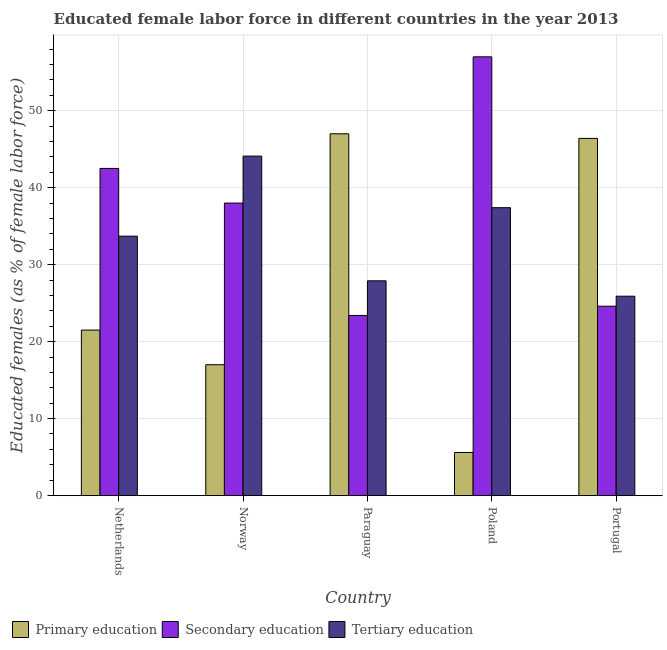How many different coloured bars are there?
Your response must be concise. 3. How many groups of bars are there?
Offer a very short reply. 5. How many bars are there on the 2nd tick from the left?
Provide a short and direct response. 3. How many bars are there on the 5th tick from the right?
Give a very brief answer. 3. What is the label of the 4th group of bars from the left?
Your answer should be very brief. Poland. What is the percentage of female labor force who received primary education in Poland?
Keep it short and to the point. 5.6. Across all countries, what is the maximum percentage of female labor force who received primary education?
Keep it short and to the point. 47. Across all countries, what is the minimum percentage of female labor force who received primary education?
Your answer should be very brief. 5.6. In which country was the percentage of female labor force who received primary education maximum?
Offer a terse response. Paraguay. In which country was the percentage of female labor force who received secondary education minimum?
Your answer should be very brief. Paraguay. What is the total percentage of female labor force who received tertiary education in the graph?
Offer a very short reply. 169. What is the difference between the percentage of female labor force who received primary education in Norway and that in Poland?
Ensure brevity in your answer.  11.4. What is the difference between the percentage of female labor force who received primary education in Norway and the percentage of female labor force who received secondary education in Netherlands?
Offer a very short reply. -25.5. What is the average percentage of female labor force who received secondary education per country?
Offer a very short reply. 37.1. What is the difference between the percentage of female labor force who received tertiary education and percentage of female labor force who received primary education in Portugal?
Keep it short and to the point. -20.5. In how many countries, is the percentage of female labor force who received primary education greater than 52 %?
Ensure brevity in your answer.  0. What is the ratio of the percentage of female labor force who received tertiary education in Netherlands to that in Norway?
Offer a terse response. 0.76. Is the percentage of female labor force who received secondary education in Norway less than that in Poland?
Provide a succinct answer. Yes. What is the difference between the highest and the second highest percentage of female labor force who received tertiary education?
Give a very brief answer. 6.7. What is the difference between the highest and the lowest percentage of female labor force who received tertiary education?
Make the answer very short. 18.2. Is the sum of the percentage of female labor force who received secondary education in Netherlands and Portugal greater than the maximum percentage of female labor force who received primary education across all countries?
Offer a very short reply. Yes. What does the 1st bar from the left in Paraguay represents?
Offer a terse response. Primary education. Are all the bars in the graph horizontal?
Your answer should be very brief. No. What is the difference between two consecutive major ticks on the Y-axis?
Provide a succinct answer. 10. Does the graph contain any zero values?
Offer a terse response. No. Does the graph contain grids?
Offer a very short reply. Yes. Where does the legend appear in the graph?
Provide a short and direct response. Bottom left. What is the title of the graph?
Ensure brevity in your answer.  Educated female labor force in different countries in the year 2013. Does "Labor Market" appear as one of the legend labels in the graph?
Your response must be concise. No. What is the label or title of the X-axis?
Provide a succinct answer. Country. What is the label or title of the Y-axis?
Offer a terse response. Educated females (as % of female labor force). What is the Educated females (as % of female labor force) in Primary education in Netherlands?
Ensure brevity in your answer.  21.5. What is the Educated females (as % of female labor force) in Secondary education in Netherlands?
Your answer should be very brief. 42.5. What is the Educated females (as % of female labor force) in Tertiary education in Netherlands?
Ensure brevity in your answer.  33.7. What is the Educated females (as % of female labor force) of Tertiary education in Norway?
Ensure brevity in your answer.  44.1. What is the Educated females (as % of female labor force) of Primary education in Paraguay?
Make the answer very short. 47. What is the Educated females (as % of female labor force) of Secondary education in Paraguay?
Your response must be concise. 23.4. What is the Educated females (as % of female labor force) of Tertiary education in Paraguay?
Make the answer very short. 27.9. What is the Educated females (as % of female labor force) in Primary education in Poland?
Offer a terse response. 5.6. What is the Educated females (as % of female labor force) in Secondary education in Poland?
Your answer should be very brief. 57. What is the Educated females (as % of female labor force) of Tertiary education in Poland?
Provide a short and direct response. 37.4. What is the Educated females (as % of female labor force) in Primary education in Portugal?
Offer a terse response. 46.4. What is the Educated females (as % of female labor force) in Secondary education in Portugal?
Give a very brief answer. 24.6. What is the Educated females (as % of female labor force) of Tertiary education in Portugal?
Your answer should be very brief. 25.9. Across all countries, what is the maximum Educated females (as % of female labor force) of Secondary education?
Your answer should be very brief. 57. Across all countries, what is the maximum Educated females (as % of female labor force) in Tertiary education?
Offer a very short reply. 44.1. Across all countries, what is the minimum Educated females (as % of female labor force) of Primary education?
Your answer should be very brief. 5.6. Across all countries, what is the minimum Educated females (as % of female labor force) of Secondary education?
Offer a terse response. 23.4. Across all countries, what is the minimum Educated females (as % of female labor force) in Tertiary education?
Keep it short and to the point. 25.9. What is the total Educated females (as % of female labor force) in Primary education in the graph?
Your answer should be compact. 137.5. What is the total Educated females (as % of female labor force) of Secondary education in the graph?
Offer a very short reply. 185.5. What is the total Educated females (as % of female labor force) in Tertiary education in the graph?
Make the answer very short. 169. What is the difference between the Educated females (as % of female labor force) of Primary education in Netherlands and that in Paraguay?
Make the answer very short. -25.5. What is the difference between the Educated females (as % of female labor force) of Secondary education in Netherlands and that in Paraguay?
Your answer should be compact. 19.1. What is the difference between the Educated females (as % of female labor force) of Tertiary education in Netherlands and that in Paraguay?
Offer a terse response. 5.8. What is the difference between the Educated females (as % of female labor force) of Primary education in Netherlands and that in Portugal?
Your answer should be very brief. -24.9. What is the difference between the Educated females (as % of female labor force) of Secondary education in Netherlands and that in Portugal?
Keep it short and to the point. 17.9. What is the difference between the Educated females (as % of female labor force) of Tertiary education in Norway and that in Paraguay?
Ensure brevity in your answer.  16.2. What is the difference between the Educated females (as % of female labor force) in Tertiary education in Norway and that in Poland?
Give a very brief answer. 6.7. What is the difference between the Educated females (as % of female labor force) in Primary education in Norway and that in Portugal?
Your response must be concise. -29.4. What is the difference between the Educated females (as % of female labor force) of Secondary education in Norway and that in Portugal?
Provide a short and direct response. 13.4. What is the difference between the Educated females (as % of female labor force) in Primary education in Paraguay and that in Poland?
Ensure brevity in your answer.  41.4. What is the difference between the Educated females (as % of female labor force) in Secondary education in Paraguay and that in Poland?
Make the answer very short. -33.6. What is the difference between the Educated females (as % of female labor force) of Secondary education in Paraguay and that in Portugal?
Ensure brevity in your answer.  -1.2. What is the difference between the Educated females (as % of female labor force) of Primary education in Poland and that in Portugal?
Provide a short and direct response. -40.8. What is the difference between the Educated females (as % of female labor force) of Secondary education in Poland and that in Portugal?
Make the answer very short. 32.4. What is the difference between the Educated females (as % of female labor force) of Primary education in Netherlands and the Educated females (as % of female labor force) of Secondary education in Norway?
Offer a terse response. -16.5. What is the difference between the Educated females (as % of female labor force) of Primary education in Netherlands and the Educated females (as % of female labor force) of Tertiary education in Norway?
Your answer should be compact. -22.6. What is the difference between the Educated females (as % of female labor force) in Secondary education in Netherlands and the Educated females (as % of female labor force) in Tertiary education in Paraguay?
Ensure brevity in your answer.  14.6. What is the difference between the Educated females (as % of female labor force) of Primary education in Netherlands and the Educated females (as % of female labor force) of Secondary education in Poland?
Your answer should be very brief. -35.5. What is the difference between the Educated females (as % of female labor force) of Primary education in Netherlands and the Educated females (as % of female labor force) of Tertiary education in Poland?
Your answer should be compact. -15.9. What is the difference between the Educated females (as % of female labor force) of Primary education in Netherlands and the Educated females (as % of female labor force) of Secondary education in Portugal?
Offer a terse response. -3.1. What is the difference between the Educated females (as % of female labor force) in Primary education in Netherlands and the Educated females (as % of female labor force) in Tertiary education in Portugal?
Your answer should be very brief. -4.4. What is the difference between the Educated females (as % of female labor force) in Secondary education in Netherlands and the Educated females (as % of female labor force) in Tertiary education in Portugal?
Offer a terse response. 16.6. What is the difference between the Educated females (as % of female labor force) of Primary education in Norway and the Educated females (as % of female labor force) of Secondary education in Paraguay?
Your response must be concise. -6.4. What is the difference between the Educated females (as % of female labor force) in Primary education in Norway and the Educated females (as % of female labor force) in Secondary education in Poland?
Provide a succinct answer. -40. What is the difference between the Educated females (as % of female labor force) of Primary education in Norway and the Educated females (as % of female labor force) of Tertiary education in Poland?
Your answer should be compact. -20.4. What is the difference between the Educated females (as % of female labor force) in Secondary education in Norway and the Educated females (as % of female labor force) in Tertiary education in Poland?
Offer a very short reply. 0.6. What is the difference between the Educated females (as % of female labor force) in Primary education in Norway and the Educated females (as % of female labor force) in Tertiary education in Portugal?
Ensure brevity in your answer.  -8.9. What is the difference between the Educated females (as % of female labor force) of Primary education in Paraguay and the Educated females (as % of female labor force) of Secondary education in Poland?
Offer a very short reply. -10. What is the difference between the Educated females (as % of female labor force) of Primary education in Paraguay and the Educated females (as % of female labor force) of Tertiary education in Poland?
Offer a very short reply. 9.6. What is the difference between the Educated females (as % of female labor force) in Secondary education in Paraguay and the Educated females (as % of female labor force) in Tertiary education in Poland?
Offer a terse response. -14. What is the difference between the Educated females (as % of female labor force) of Primary education in Paraguay and the Educated females (as % of female labor force) of Secondary education in Portugal?
Provide a short and direct response. 22.4. What is the difference between the Educated females (as % of female labor force) in Primary education in Paraguay and the Educated females (as % of female labor force) in Tertiary education in Portugal?
Keep it short and to the point. 21.1. What is the difference between the Educated females (as % of female labor force) in Secondary education in Paraguay and the Educated females (as % of female labor force) in Tertiary education in Portugal?
Your answer should be very brief. -2.5. What is the difference between the Educated females (as % of female labor force) in Primary education in Poland and the Educated females (as % of female labor force) in Tertiary education in Portugal?
Provide a succinct answer. -20.3. What is the difference between the Educated females (as % of female labor force) in Secondary education in Poland and the Educated females (as % of female labor force) in Tertiary education in Portugal?
Keep it short and to the point. 31.1. What is the average Educated females (as % of female labor force) in Secondary education per country?
Ensure brevity in your answer.  37.1. What is the average Educated females (as % of female labor force) of Tertiary education per country?
Keep it short and to the point. 33.8. What is the difference between the Educated females (as % of female labor force) in Primary education and Educated females (as % of female labor force) in Tertiary education in Netherlands?
Offer a very short reply. -12.2. What is the difference between the Educated females (as % of female labor force) of Secondary education and Educated females (as % of female labor force) of Tertiary education in Netherlands?
Keep it short and to the point. 8.8. What is the difference between the Educated females (as % of female labor force) of Primary education and Educated females (as % of female labor force) of Secondary education in Norway?
Your answer should be very brief. -21. What is the difference between the Educated females (as % of female labor force) of Primary education and Educated females (as % of female labor force) of Tertiary education in Norway?
Provide a short and direct response. -27.1. What is the difference between the Educated females (as % of female labor force) in Secondary education and Educated females (as % of female labor force) in Tertiary education in Norway?
Your response must be concise. -6.1. What is the difference between the Educated females (as % of female labor force) of Primary education and Educated females (as % of female labor force) of Secondary education in Paraguay?
Offer a terse response. 23.6. What is the difference between the Educated females (as % of female labor force) in Primary education and Educated females (as % of female labor force) in Secondary education in Poland?
Offer a very short reply. -51.4. What is the difference between the Educated females (as % of female labor force) of Primary education and Educated females (as % of female labor force) of Tertiary education in Poland?
Give a very brief answer. -31.8. What is the difference between the Educated females (as % of female labor force) of Secondary education and Educated females (as % of female labor force) of Tertiary education in Poland?
Ensure brevity in your answer.  19.6. What is the difference between the Educated females (as % of female labor force) in Primary education and Educated females (as % of female labor force) in Secondary education in Portugal?
Offer a very short reply. 21.8. What is the difference between the Educated females (as % of female labor force) in Secondary education and Educated females (as % of female labor force) in Tertiary education in Portugal?
Keep it short and to the point. -1.3. What is the ratio of the Educated females (as % of female labor force) in Primary education in Netherlands to that in Norway?
Ensure brevity in your answer.  1.26. What is the ratio of the Educated females (as % of female labor force) in Secondary education in Netherlands to that in Norway?
Keep it short and to the point. 1.12. What is the ratio of the Educated females (as % of female labor force) of Tertiary education in Netherlands to that in Norway?
Make the answer very short. 0.76. What is the ratio of the Educated females (as % of female labor force) in Primary education in Netherlands to that in Paraguay?
Your answer should be very brief. 0.46. What is the ratio of the Educated females (as % of female labor force) in Secondary education in Netherlands to that in Paraguay?
Make the answer very short. 1.82. What is the ratio of the Educated females (as % of female labor force) in Tertiary education in Netherlands to that in Paraguay?
Make the answer very short. 1.21. What is the ratio of the Educated females (as % of female labor force) of Primary education in Netherlands to that in Poland?
Ensure brevity in your answer.  3.84. What is the ratio of the Educated females (as % of female labor force) of Secondary education in Netherlands to that in Poland?
Your answer should be compact. 0.75. What is the ratio of the Educated females (as % of female labor force) in Tertiary education in Netherlands to that in Poland?
Ensure brevity in your answer.  0.9. What is the ratio of the Educated females (as % of female labor force) in Primary education in Netherlands to that in Portugal?
Your response must be concise. 0.46. What is the ratio of the Educated females (as % of female labor force) in Secondary education in Netherlands to that in Portugal?
Your answer should be compact. 1.73. What is the ratio of the Educated females (as % of female labor force) in Tertiary education in Netherlands to that in Portugal?
Offer a terse response. 1.3. What is the ratio of the Educated females (as % of female labor force) in Primary education in Norway to that in Paraguay?
Your answer should be very brief. 0.36. What is the ratio of the Educated females (as % of female labor force) of Secondary education in Norway to that in Paraguay?
Keep it short and to the point. 1.62. What is the ratio of the Educated females (as % of female labor force) in Tertiary education in Norway to that in Paraguay?
Make the answer very short. 1.58. What is the ratio of the Educated females (as % of female labor force) of Primary education in Norway to that in Poland?
Your answer should be very brief. 3.04. What is the ratio of the Educated females (as % of female labor force) in Secondary education in Norway to that in Poland?
Your response must be concise. 0.67. What is the ratio of the Educated females (as % of female labor force) in Tertiary education in Norway to that in Poland?
Your response must be concise. 1.18. What is the ratio of the Educated females (as % of female labor force) in Primary education in Norway to that in Portugal?
Offer a terse response. 0.37. What is the ratio of the Educated females (as % of female labor force) of Secondary education in Norway to that in Portugal?
Your answer should be very brief. 1.54. What is the ratio of the Educated females (as % of female labor force) in Tertiary education in Norway to that in Portugal?
Give a very brief answer. 1.7. What is the ratio of the Educated females (as % of female labor force) of Primary education in Paraguay to that in Poland?
Your response must be concise. 8.39. What is the ratio of the Educated females (as % of female labor force) in Secondary education in Paraguay to that in Poland?
Offer a terse response. 0.41. What is the ratio of the Educated females (as % of female labor force) in Tertiary education in Paraguay to that in Poland?
Keep it short and to the point. 0.75. What is the ratio of the Educated females (as % of female labor force) in Primary education in Paraguay to that in Portugal?
Ensure brevity in your answer.  1.01. What is the ratio of the Educated females (as % of female labor force) of Secondary education in Paraguay to that in Portugal?
Offer a terse response. 0.95. What is the ratio of the Educated females (as % of female labor force) in Tertiary education in Paraguay to that in Portugal?
Provide a succinct answer. 1.08. What is the ratio of the Educated females (as % of female labor force) in Primary education in Poland to that in Portugal?
Give a very brief answer. 0.12. What is the ratio of the Educated females (as % of female labor force) of Secondary education in Poland to that in Portugal?
Keep it short and to the point. 2.32. What is the ratio of the Educated females (as % of female labor force) in Tertiary education in Poland to that in Portugal?
Your answer should be compact. 1.44. What is the difference between the highest and the lowest Educated females (as % of female labor force) in Primary education?
Give a very brief answer. 41.4. What is the difference between the highest and the lowest Educated females (as % of female labor force) in Secondary education?
Keep it short and to the point. 33.6. 